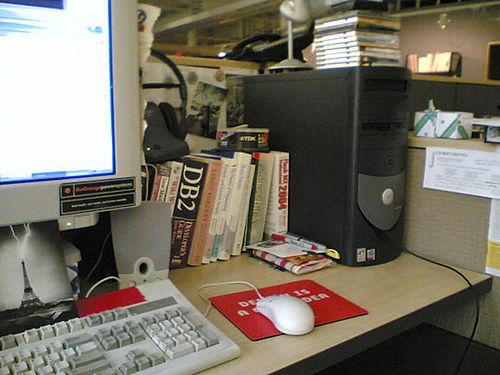Is the mouse on the red square an animal?
Quick response, please. No. What color is the computer tower?
Quick response, please. Black. What landmark is pictured on the left?
Concise answer only. Eiffel tower. 